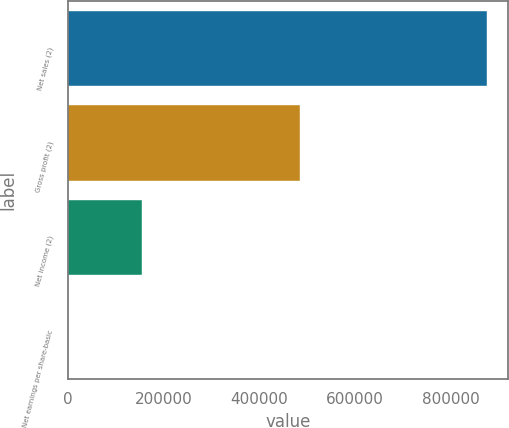<chart> <loc_0><loc_0><loc_500><loc_500><bar_chart><fcel>Net sales (2)<fcel>Gross profit (2)<fcel>Net income (2)<fcel>Net earnings per share-basic<nl><fcel>875223<fcel>484319<fcel>154668<fcel>2.77<nl></chart> 